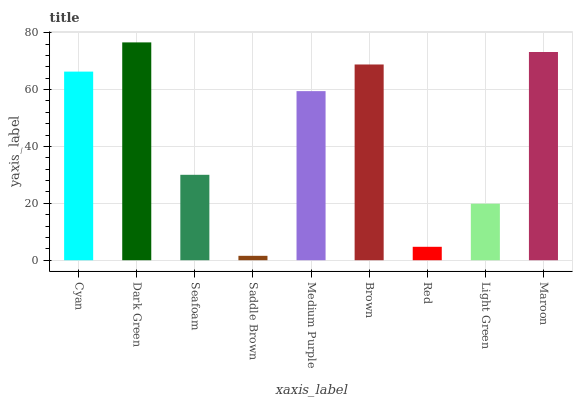Is Saddle Brown the minimum?
Answer yes or no. Yes. Is Dark Green the maximum?
Answer yes or no. Yes. Is Seafoam the minimum?
Answer yes or no. No. Is Seafoam the maximum?
Answer yes or no. No. Is Dark Green greater than Seafoam?
Answer yes or no. Yes. Is Seafoam less than Dark Green?
Answer yes or no. Yes. Is Seafoam greater than Dark Green?
Answer yes or no. No. Is Dark Green less than Seafoam?
Answer yes or no. No. Is Medium Purple the high median?
Answer yes or no. Yes. Is Medium Purple the low median?
Answer yes or no. Yes. Is Cyan the high median?
Answer yes or no. No. Is Brown the low median?
Answer yes or no. No. 